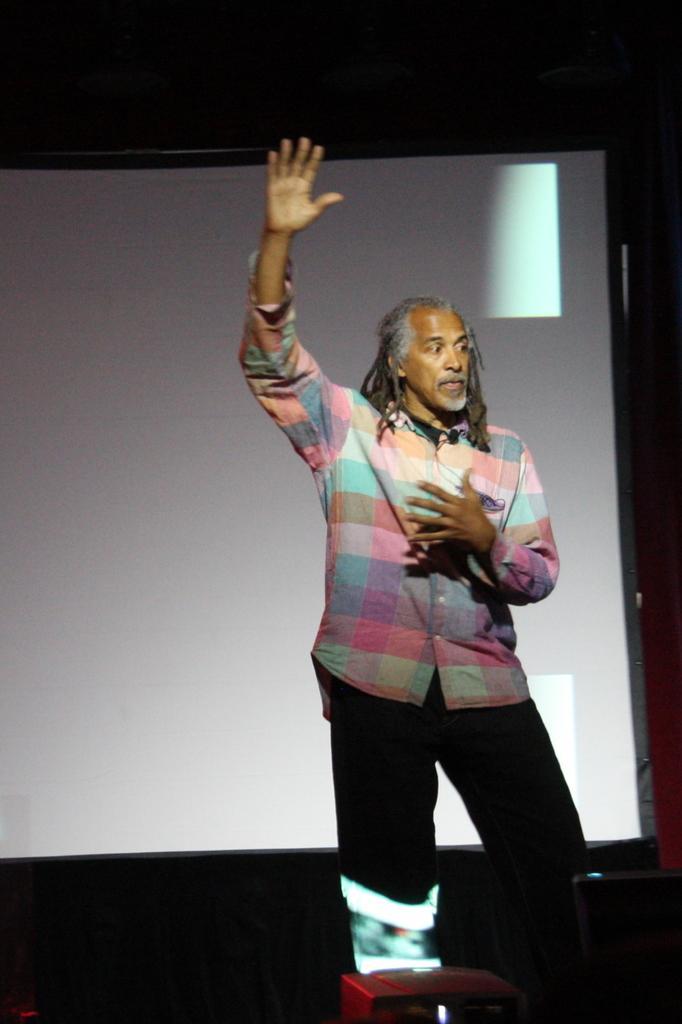In one or two sentences, can you explain what this image depicts? In this image I can see the person with colorful dress. At the back of the person I can see the screen. And there is a black background. 